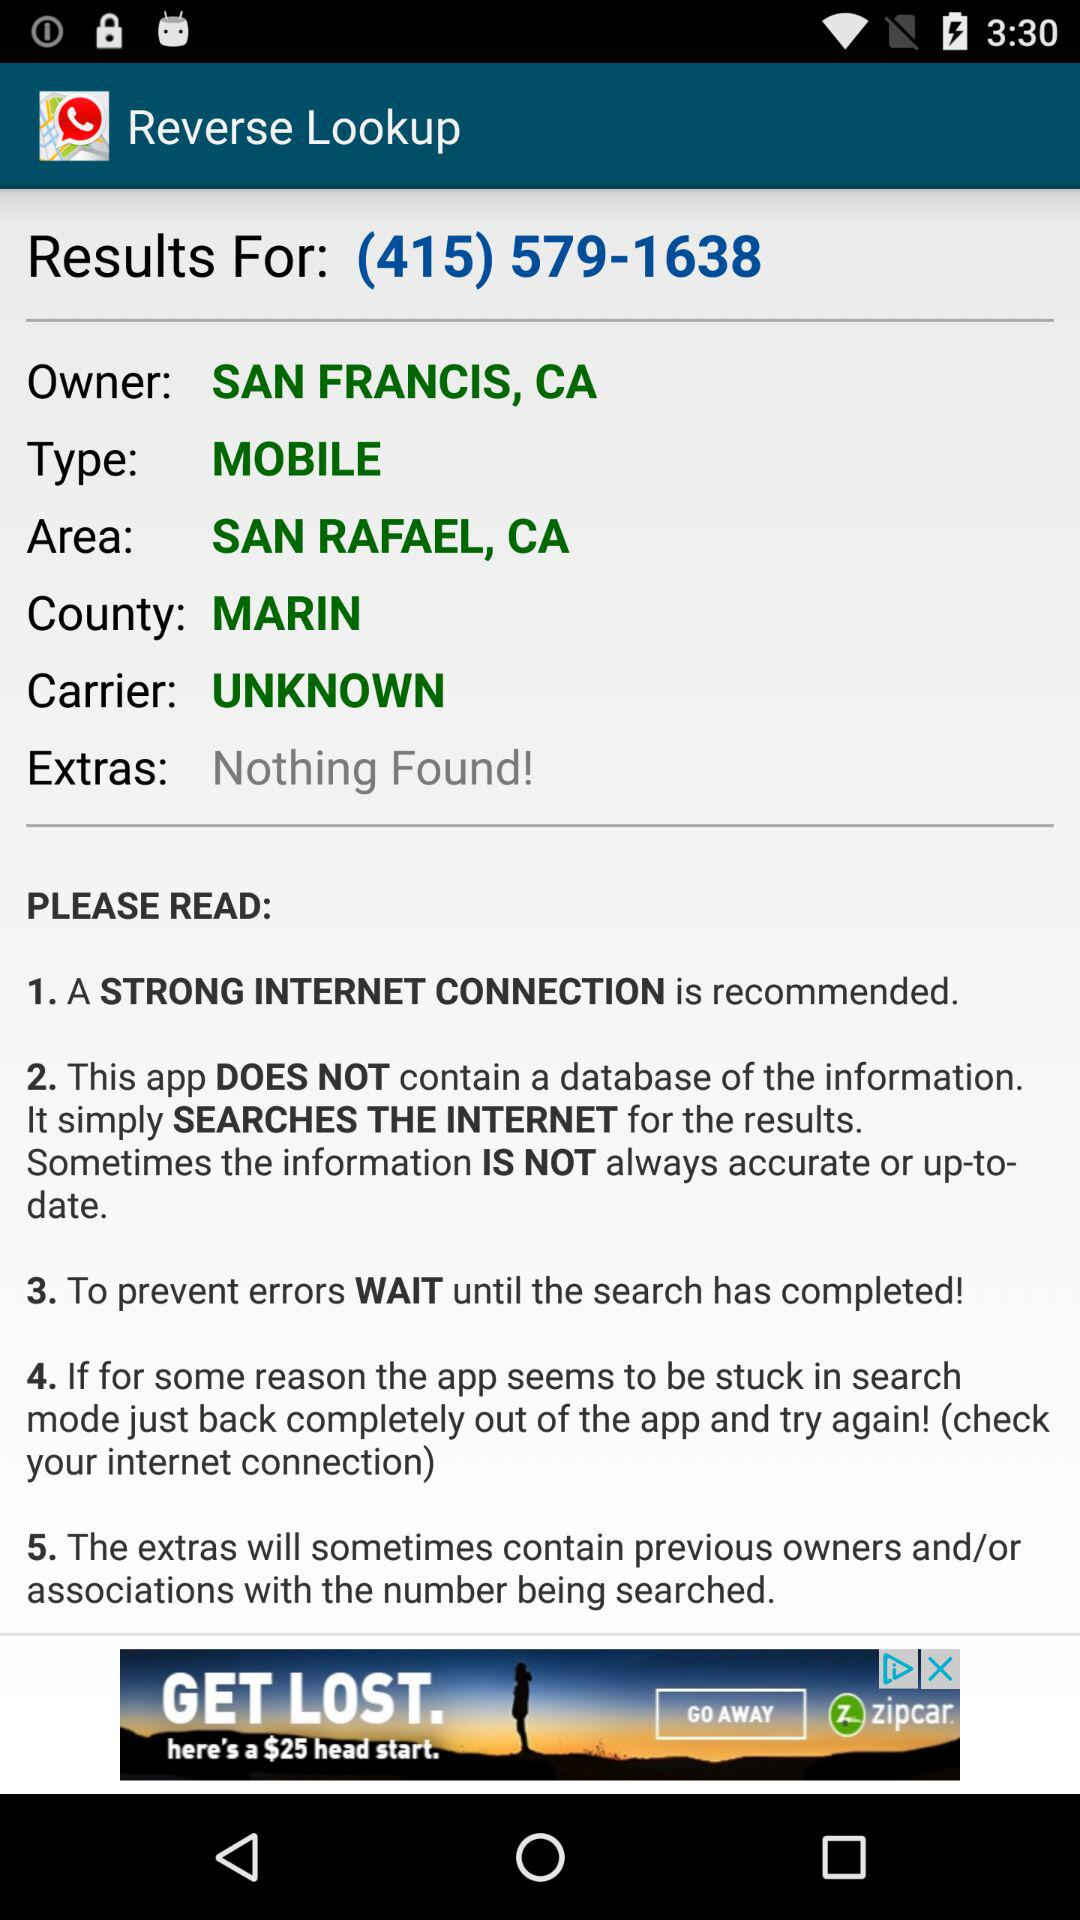What is the county name? The county name is Marin. 